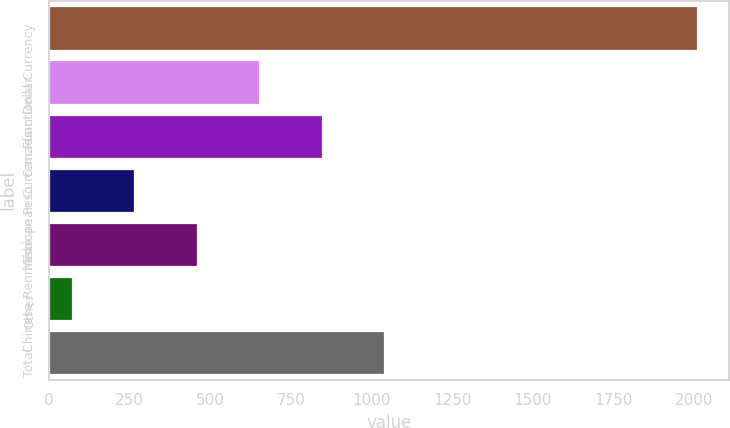Convert chart. <chart><loc_0><loc_0><loc_500><loc_500><bar_chart><fcel>Functional Currency<fcel>Canadian Dollar<fcel>European Currencies<fcel>Mexican Peso<fcel>Chinese Renminbi<fcel>Other<fcel>Total<nl><fcel>2007<fcel>651.59<fcel>845.22<fcel>264.33<fcel>457.96<fcel>70.7<fcel>1038.85<nl></chart> 